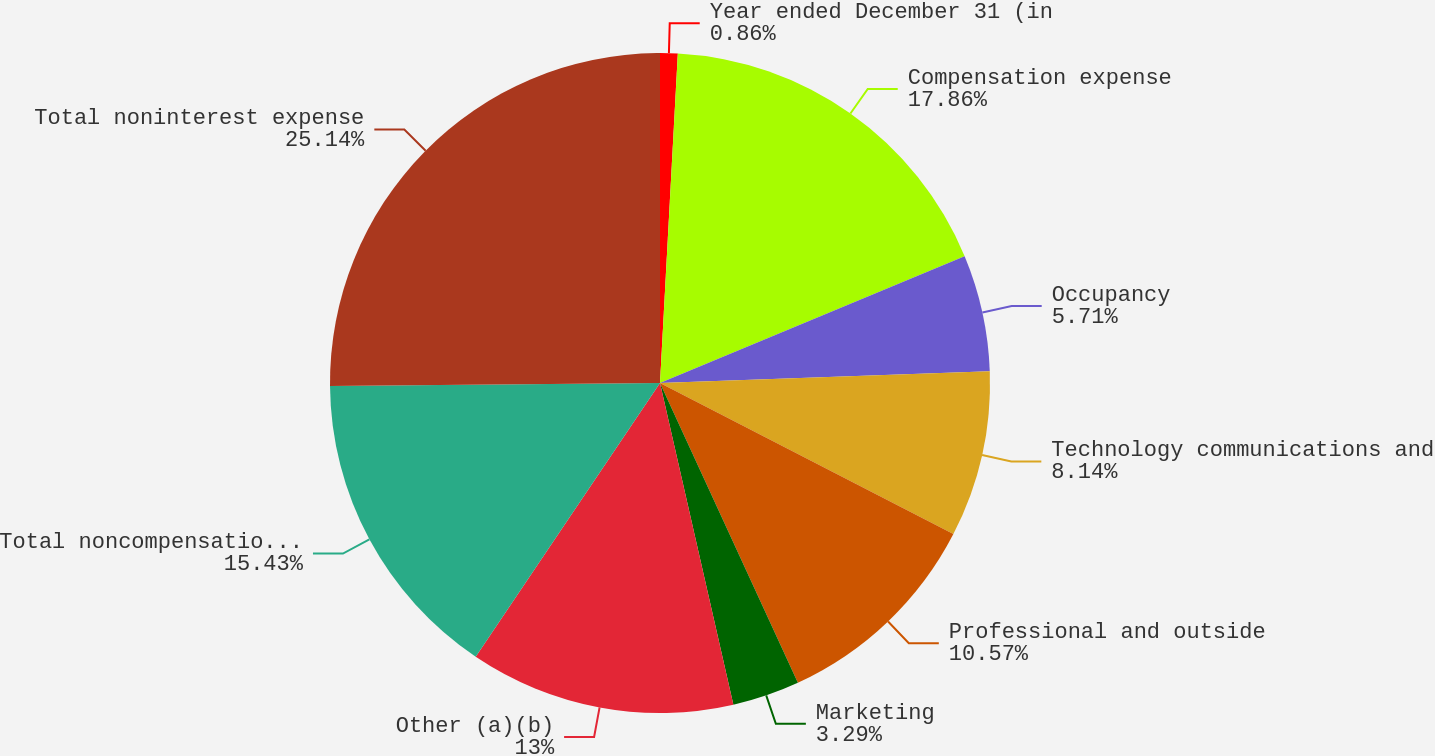Convert chart to OTSL. <chart><loc_0><loc_0><loc_500><loc_500><pie_chart><fcel>Year ended December 31 (in<fcel>Compensation expense<fcel>Occupancy<fcel>Technology communications and<fcel>Professional and outside<fcel>Marketing<fcel>Other (a)(b)<fcel>Total noncompensation expense<fcel>Total noninterest expense<nl><fcel>0.86%<fcel>17.86%<fcel>5.71%<fcel>8.14%<fcel>10.57%<fcel>3.29%<fcel>13.0%<fcel>15.43%<fcel>25.14%<nl></chart> 